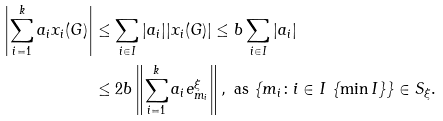Convert formula to latex. <formula><loc_0><loc_0><loc_500><loc_500>\left | \sum _ { i = 1 } ^ { k } a _ { i } x _ { i } ( G ) \right | & \leq \sum _ { i \in I } | a _ { i } | | x _ { i } ( G ) | \leq b \sum _ { i \in I } | a _ { i } | \\ & \leq 2 b \left \| \sum _ { i = 1 } ^ { k } a _ { i } e _ { m _ { i } } ^ { \xi } \right \| , \text { as } \{ m _ { i } \colon i \in I \ \{ \min I \} \} \in S _ { \xi } .</formula> 